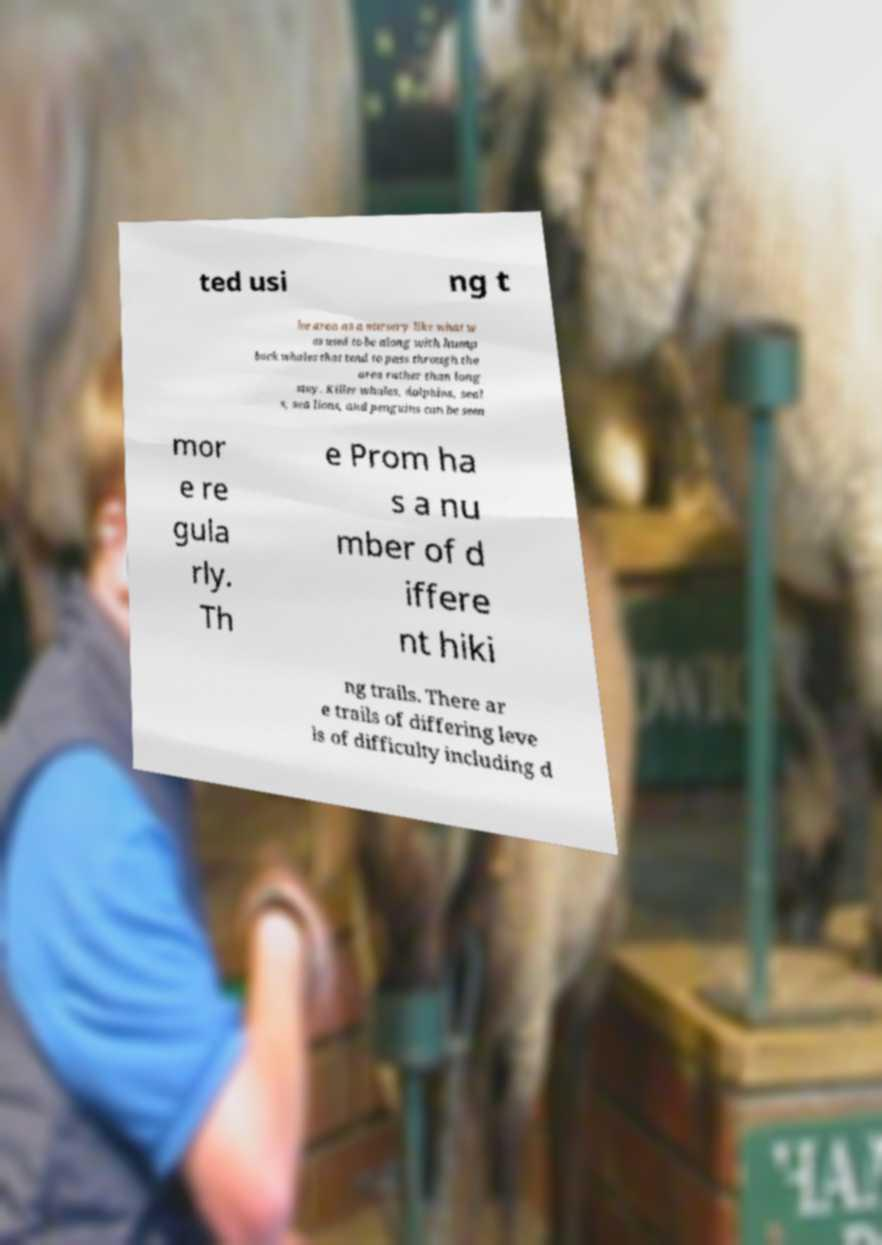Could you extract and type out the text from this image? ted usi ng t he area as a nursery like what w as used to be along with hump back whales that tend to pass through the area rather than long stay. Killer whales, dolphins, seal s, sea lions, and penguins can be seen mor e re gula rly. Th e Prom ha s a nu mber of d iffere nt hiki ng trails. There ar e trails of differing leve ls of difficulty including d 